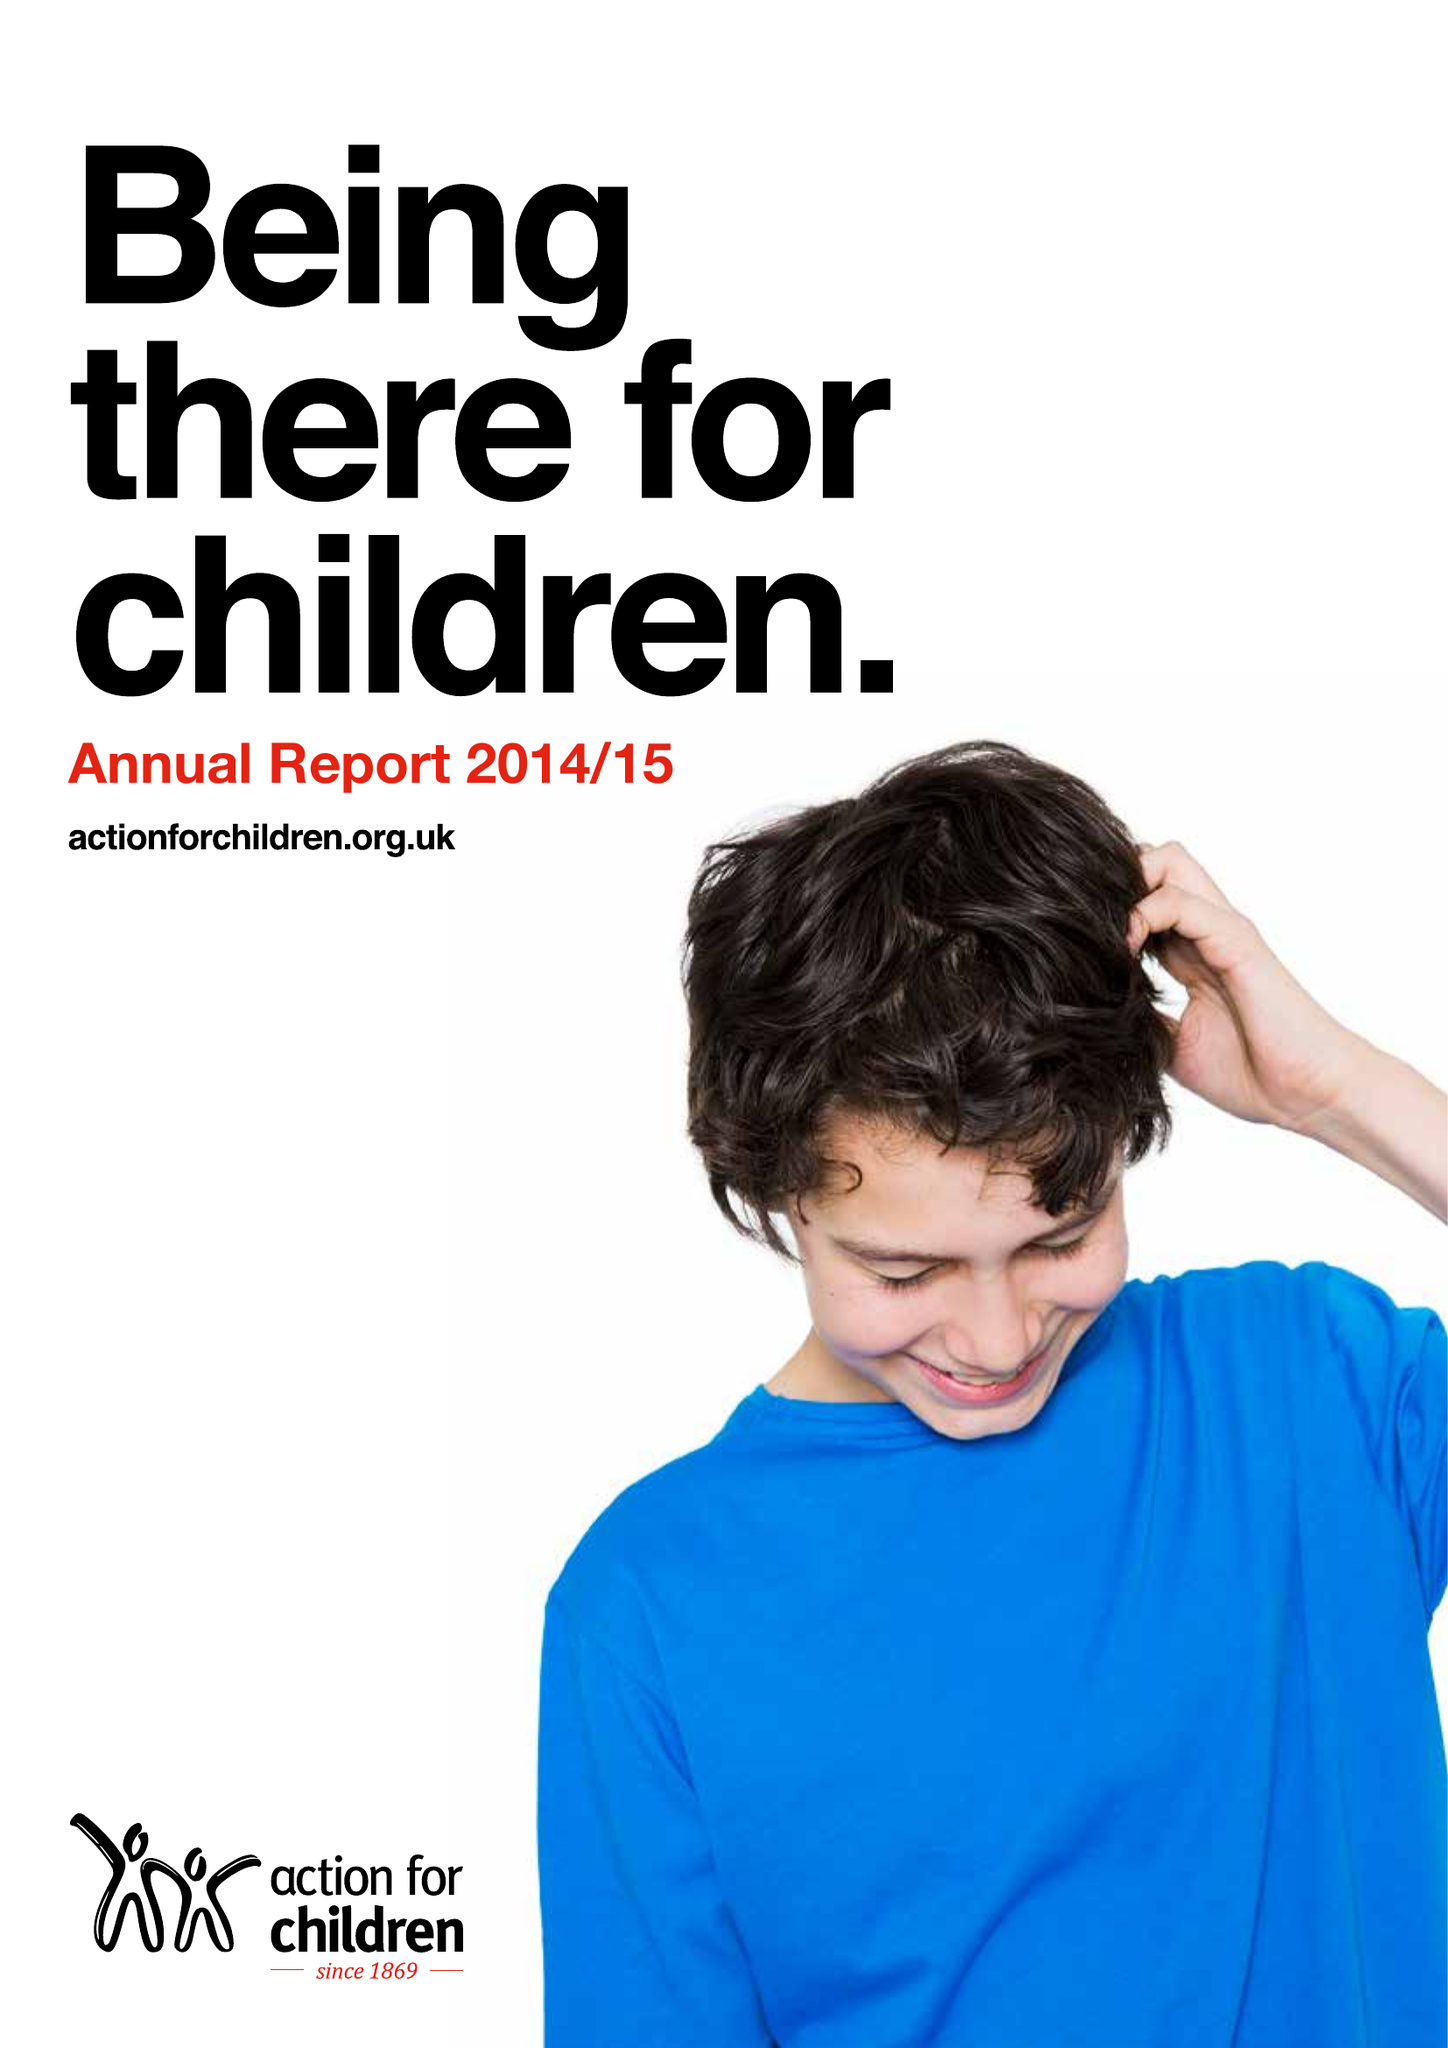What is the value for the charity_number?
Answer the question using a single word or phrase. 1097940 